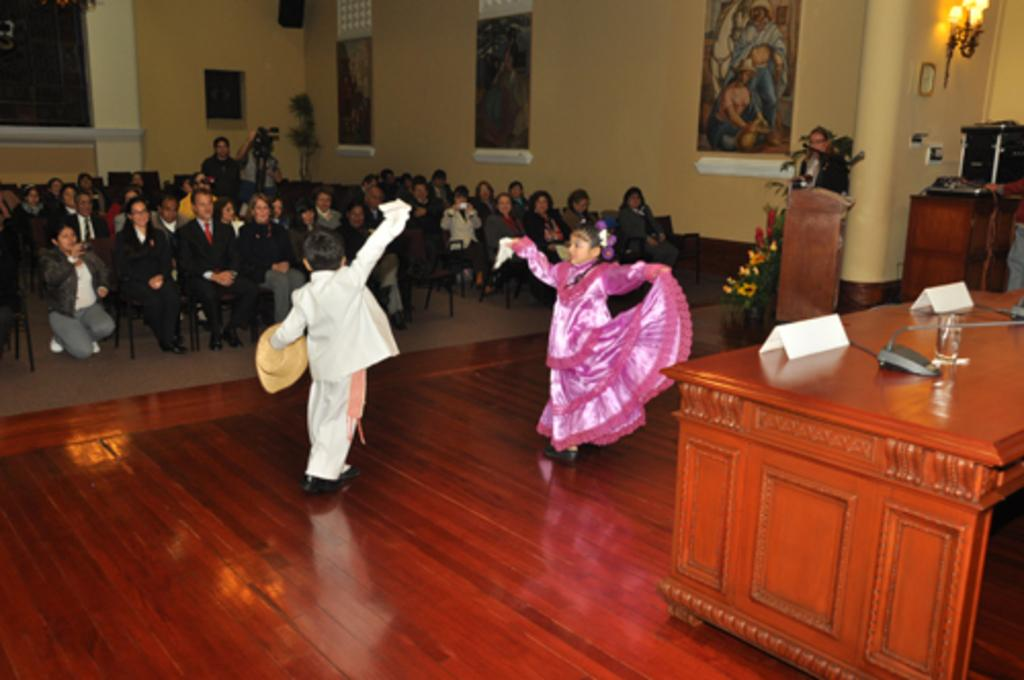What are the people in the image doing? There is a group of people sitting in chairs, and a boy and a girl are dancing. What can be seen on the wall in the background? There is a frame attached to the wall in the background. What other objects are visible in the background? There is a lamp, a table, a name board, a glass, and a plant in the background. What type of minister is present in the image? There is no minister present in the image. What happens to the glass when the boy and girl start dancing? The glass does not move or change in any way when the boy and girl start dancing; it remains stationary in the background. 